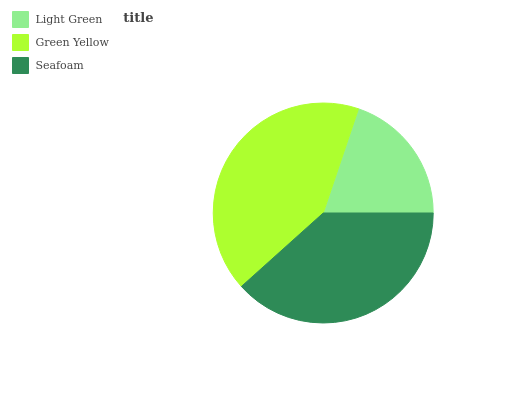Is Light Green the minimum?
Answer yes or no. Yes. Is Green Yellow the maximum?
Answer yes or no. Yes. Is Seafoam the minimum?
Answer yes or no. No. Is Seafoam the maximum?
Answer yes or no. No. Is Green Yellow greater than Seafoam?
Answer yes or no. Yes. Is Seafoam less than Green Yellow?
Answer yes or no. Yes. Is Seafoam greater than Green Yellow?
Answer yes or no. No. Is Green Yellow less than Seafoam?
Answer yes or no. No. Is Seafoam the high median?
Answer yes or no. Yes. Is Seafoam the low median?
Answer yes or no. Yes. Is Green Yellow the high median?
Answer yes or no. No. Is Light Green the low median?
Answer yes or no. No. 